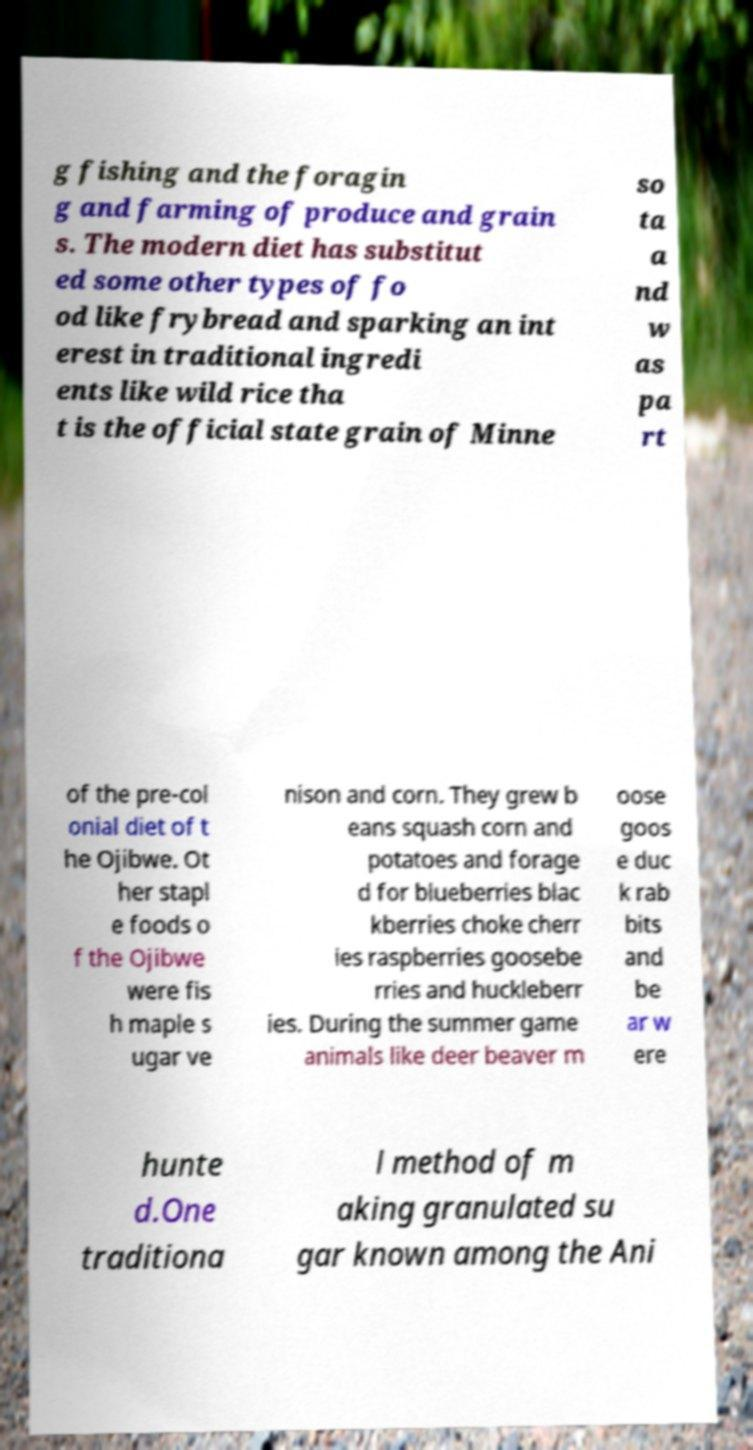Can you read and provide the text displayed in the image?This photo seems to have some interesting text. Can you extract and type it out for me? g fishing and the foragin g and farming of produce and grain s. The modern diet has substitut ed some other types of fo od like frybread and sparking an int erest in traditional ingredi ents like wild rice tha t is the official state grain of Minne so ta a nd w as pa rt of the pre-col onial diet of t he Ojibwe. Ot her stapl e foods o f the Ojibwe were fis h maple s ugar ve nison and corn. They grew b eans squash corn and potatoes and forage d for blueberries blac kberries choke cherr ies raspberries goosebe rries and huckleberr ies. During the summer game animals like deer beaver m oose goos e duc k rab bits and be ar w ere hunte d.One traditiona l method of m aking granulated su gar known among the Ani 